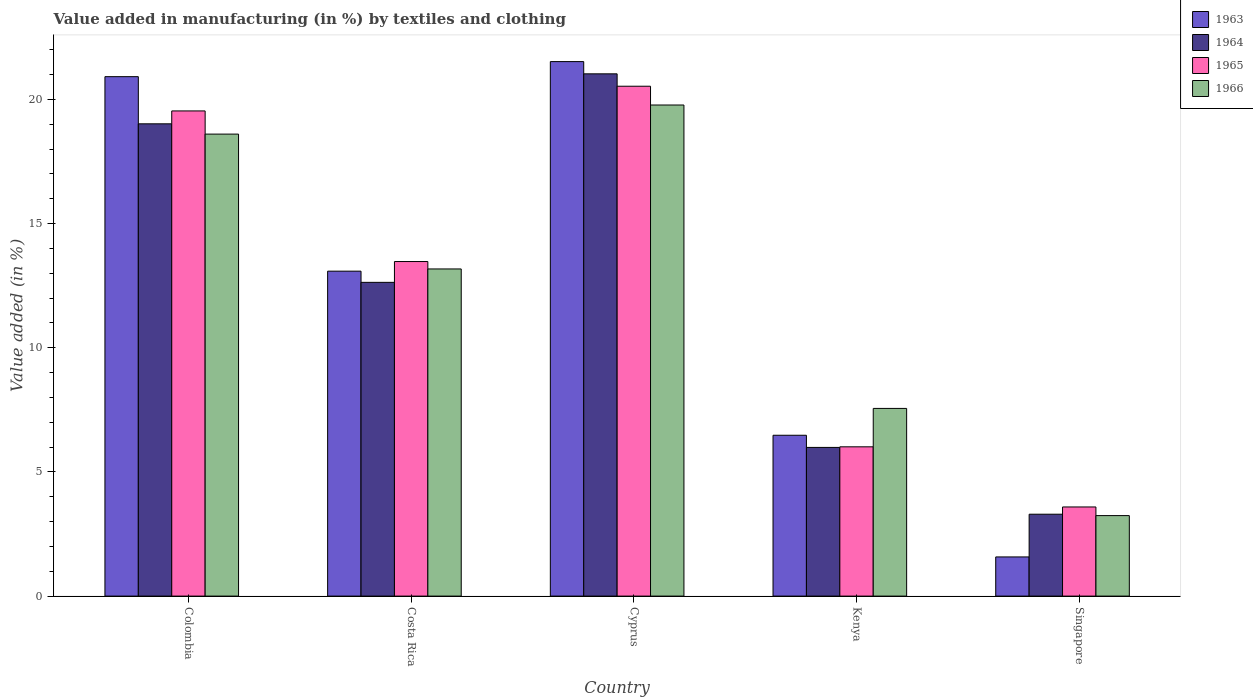How many groups of bars are there?
Keep it short and to the point. 5. Are the number of bars per tick equal to the number of legend labels?
Your answer should be compact. Yes. How many bars are there on the 3rd tick from the left?
Provide a succinct answer. 4. What is the percentage of value added in manufacturing by textiles and clothing in 1963 in Colombia?
Provide a succinct answer. 20.92. Across all countries, what is the maximum percentage of value added in manufacturing by textiles and clothing in 1964?
Provide a succinct answer. 21.03. Across all countries, what is the minimum percentage of value added in manufacturing by textiles and clothing in 1965?
Your answer should be very brief. 3.59. In which country was the percentage of value added in manufacturing by textiles and clothing in 1963 maximum?
Provide a succinct answer. Cyprus. In which country was the percentage of value added in manufacturing by textiles and clothing in 1963 minimum?
Provide a succinct answer. Singapore. What is the total percentage of value added in manufacturing by textiles and clothing in 1963 in the graph?
Make the answer very short. 63.58. What is the difference between the percentage of value added in manufacturing by textiles and clothing in 1964 in Cyprus and that in Singapore?
Keep it short and to the point. 17.73. What is the difference between the percentage of value added in manufacturing by textiles and clothing in 1965 in Costa Rica and the percentage of value added in manufacturing by textiles and clothing in 1966 in Kenya?
Offer a very short reply. 5.91. What is the average percentage of value added in manufacturing by textiles and clothing in 1963 per country?
Give a very brief answer. 12.72. What is the difference between the percentage of value added in manufacturing by textiles and clothing of/in 1966 and percentage of value added in manufacturing by textiles and clothing of/in 1963 in Costa Rica?
Your answer should be very brief. 0.09. In how many countries, is the percentage of value added in manufacturing by textiles and clothing in 1966 greater than 7 %?
Offer a very short reply. 4. What is the ratio of the percentage of value added in manufacturing by textiles and clothing in 1966 in Colombia to that in Costa Rica?
Your answer should be compact. 1.41. Is the percentage of value added in manufacturing by textiles and clothing in 1964 in Colombia less than that in Singapore?
Keep it short and to the point. No. What is the difference between the highest and the second highest percentage of value added in manufacturing by textiles and clothing in 1966?
Keep it short and to the point. -1.17. What is the difference between the highest and the lowest percentage of value added in manufacturing by textiles and clothing in 1964?
Your response must be concise. 17.73. Is the sum of the percentage of value added in manufacturing by textiles and clothing in 1966 in Cyprus and Kenya greater than the maximum percentage of value added in manufacturing by textiles and clothing in 1965 across all countries?
Provide a succinct answer. Yes. Is it the case that in every country, the sum of the percentage of value added in manufacturing by textiles and clothing in 1964 and percentage of value added in manufacturing by textiles and clothing in 1966 is greater than the sum of percentage of value added in manufacturing by textiles and clothing in 1965 and percentage of value added in manufacturing by textiles and clothing in 1963?
Offer a terse response. No. What does the 3rd bar from the left in Costa Rica represents?
Ensure brevity in your answer.  1965. What does the 2nd bar from the right in Colombia represents?
Your answer should be very brief. 1965. Is it the case that in every country, the sum of the percentage of value added in manufacturing by textiles and clothing in 1965 and percentage of value added in manufacturing by textiles and clothing in 1963 is greater than the percentage of value added in manufacturing by textiles and clothing in 1966?
Make the answer very short. Yes. Are all the bars in the graph horizontal?
Your answer should be very brief. No. What is the difference between two consecutive major ticks on the Y-axis?
Your answer should be compact. 5. How many legend labels are there?
Your answer should be compact. 4. What is the title of the graph?
Your response must be concise. Value added in manufacturing (in %) by textiles and clothing. Does "2013" appear as one of the legend labels in the graph?
Provide a short and direct response. No. What is the label or title of the Y-axis?
Provide a succinct answer. Value added (in %). What is the Value added (in %) in 1963 in Colombia?
Your response must be concise. 20.92. What is the Value added (in %) of 1964 in Colombia?
Your response must be concise. 19.02. What is the Value added (in %) in 1965 in Colombia?
Ensure brevity in your answer.  19.54. What is the Value added (in %) of 1966 in Colombia?
Provide a succinct answer. 18.6. What is the Value added (in %) of 1963 in Costa Rica?
Offer a very short reply. 13.08. What is the Value added (in %) of 1964 in Costa Rica?
Provide a short and direct response. 12.63. What is the Value added (in %) in 1965 in Costa Rica?
Keep it short and to the point. 13.47. What is the Value added (in %) in 1966 in Costa Rica?
Keep it short and to the point. 13.17. What is the Value added (in %) of 1963 in Cyprus?
Ensure brevity in your answer.  21.52. What is the Value added (in %) in 1964 in Cyprus?
Offer a very short reply. 21.03. What is the Value added (in %) of 1965 in Cyprus?
Your response must be concise. 20.53. What is the Value added (in %) in 1966 in Cyprus?
Your answer should be very brief. 19.78. What is the Value added (in %) of 1963 in Kenya?
Offer a terse response. 6.48. What is the Value added (in %) of 1964 in Kenya?
Give a very brief answer. 5.99. What is the Value added (in %) of 1965 in Kenya?
Ensure brevity in your answer.  6.01. What is the Value added (in %) in 1966 in Kenya?
Ensure brevity in your answer.  7.56. What is the Value added (in %) of 1963 in Singapore?
Your answer should be compact. 1.58. What is the Value added (in %) of 1964 in Singapore?
Your response must be concise. 3.3. What is the Value added (in %) in 1965 in Singapore?
Ensure brevity in your answer.  3.59. What is the Value added (in %) in 1966 in Singapore?
Your answer should be very brief. 3.24. Across all countries, what is the maximum Value added (in %) in 1963?
Keep it short and to the point. 21.52. Across all countries, what is the maximum Value added (in %) in 1964?
Make the answer very short. 21.03. Across all countries, what is the maximum Value added (in %) in 1965?
Your response must be concise. 20.53. Across all countries, what is the maximum Value added (in %) of 1966?
Your response must be concise. 19.78. Across all countries, what is the minimum Value added (in %) of 1963?
Your answer should be compact. 1.58. Across all countries, what is the minimum Value added (in %) in 1964?
Make the answer very short. 3.3. Across all countries, what is the minimum Value added (in %) of 1965?
Make the answer very short. 3.59. Across all countries, what is the minimum Value added (in %) of 1966?
Your answer should be very brief. 3.24. What is the total Value added (in %) in 1963 in the graph?
Provide a succinct answer. 63.58. What is the total Value added (in %) in 1964 in the graph?
Give a very brief answer. 61.97. What is the total Value added (in %) in 1965 in the graph?
Make the answer very short. 63.14. What is the total Value added (in %) in 1966 in the graph?
Keep it short and to the point. 62.35. What is the difference between the Value added (in %) in 1963 in Colombia and that in Costa Rica?
Your response must be concise. 7.83. What is the difference between the Value added (in %) of 1964 in Colombia and that in Costa Rica?
Ensure brevity in your answer.  6.38. What is the difference between the Value added (in %) of 1965 in Colombia and that in Costa Rica?
Offer a terse response. 6.06. What is the difference between the Value added (in %) in 1966 in Colombia and that in Costa Rica?
Provide a succinct answer. 5.43. What is the difference between the Value added (in %) in 1963 in Colombia and that in Cyprus?
Provide a short and direct response. -0.61. What is the difference between the Value added (in %) of 1964 in Colombia and that in Cyprus?
Your answer should be very brief. -2.01. What is the difference between the Value added (in %) of 1965 in Colombia and that in Cyprus?
Ensure brevity in your answer.  -0.99. What is the difference between the Value added (in %) of 1966 in Colombia and that in Cyprus?
Give a very brief answer. -1.17. What is the difference between the Value added (in %) in 1963 in Colombia and that in Kenya?
Offer a very short reply. 14.44. What is the difference between the Value added (in %) of 1964 in Colombia and that in Kenya?
Your answer should be compact. 13.03. What is the difference between the Value added (in %) of 1965 in Colombia and that in Kenya?
Give a very brief answer. 13.53. What is the difference between the Value added (in %) in 1966 in Colombia and that in Kenya?
Provide a succinct answer. 11.05. What is the difference between the Value added (in %) of 1963 in Colombia and that in Singapore?
Give a very brief answer. 19.34. What is the difference between the Value added (in %) in 1964 in Colombia and that in Singapore?
Offer a very short reply. 15.72. What is the difference between the Value added (in %) in 1965 in Colombia and that in Singapore?
Make the answer very short. 15.95. What is the difference between the Value added (in %) in 1966 in Colombia and that in Singapore?
Offer a terse response. 15.36. What is the difference between the Value added (in %) of 1963 in Costa Rica and that in Cyprus?
Make the answer very short. -8.44. What is the difference between the Value added (in %) in 1964 in Costa Rica and that in Cyprus?
Offer a terse response. -8.4. What is the difference between the Value added (in %) in 1965 in Costa Rica and that in Cyprus?
Your answer should be compact. -7.06. What is the difference between the Value added (in %) of 1966 in Costa Rica and that in Cyprus?
Your answer should be very brief. -6.6. What is the difference between the Value added (in %) of 1963 in Costa Rica and that in Kenya?
Your answer should be very brief. 6.61. What is the difference between the Value added (in %) in 1964 in Costa Rica and that in Kenya?
Your answer should be very brief. 6.65. What is the difference between the Value added (in %) in 1965 in Costa Rica and that in Kenya?
Your answer should be compact. 7.46. What is the difference between the Value added (in %) of 1966 in Costa Rica and that in Kenya?
Your response must be concise. 5.62. What is the difference between the Value added (in %) in 1963 in Costa Rica and that in Singapore?
Your answer should be very brief. 11.51. What is the difference between the Value added (in %) in 1964 in Costa Rica and that in Singapore?
Make the answer very short. 9.34. What is the difference between the Value added (in %) in 1965 in Costa Rica and that in Singapore?
Your answer should be very brief. 9.88. What is the difference between the Value added (in %) of 1966 in Costa Rica and that in Singapore?
Your answer should be very brief. 9.93. What is the difference between the Value added (in %) in 1963 in Cyprus and that in Kenya?
Your answer should be very brief. 15.05. What is the difference between the Value added (in %) of 1964 in Cyprus and that in Kenya?
Your response must be concise. 15.04. What is the difference between the Value added (in %) of 1965 in Cyprus and that in Kenya?
Your response must be concise. 14.52. What is the difference between the Value added (in %) in 1966 in Cyprus and that in Kenya?
Provide a short and direct response. 12.22. What is the difference between the Value added (in %) in 1963 in Cyprus and that in Singapore?
Offer a terse response. 19.95. What is the difference between the Value added (in %) of 1964 in Cyprus and that in Singapore?
Offer a very short reply. 17.73. What is the difference between the Value added (in %) of 1965 in Cyprus and that in Singapore?
Provide a succinct answer. 16.94. What is the difference between the Value added (in %) in 1966 in Cyprus and that in Singapore?
Offer a very short reply. 16.53. What is the difference between the Value added (in %) of 1963 in Kenya and that in Singapore?
Offer a very short reply. 4.9. What is the difference between the Value added (in %) in 1964 in Kenya and that in Singapore?
Offer a very short reply. 2.69. What is the difference between the Value added (in %) of 1965 in Kenya and that in Singapore?
Ensure brevity in your answer.  2.42. What is the difference between the Value added (in %) of 1966 in Kenya and that in Singapore?
Keep it short and to the point. 4.32. What is the difference between the Value added (in %) of 1963 in Colombia and the Value added (in %) of 1964 in Costa Rica?
Keep it short and to the point. 8.28. What is the difference between the Value added (in %) in 1963 in Colombia and the Value added (in %) in 1965 in Costa Rica?
Your answer should be compact. 7.44. What is the difference between the Value added (in %) in 1963 in Colombia and the Value added (in %) in 1966 in Costa Rica?
Offer a terse response. 7.74. What is the difference between the Value added (in %) in 1964 in Colombia and the Value added (in %) in 1965 in Costa Rica?
Make the answer very short. 5.55. What is the difference between the Value added (in %) of 1964 in Colombia and the Value added (in %) of 1966 in Costa Rica?
Your answer should be very brief. 5.84. What is the difference between the Value added (in %) in 1965 in Colombia and the Value added (in %) in 1966 in Costa Rica?
Offer a very short reply. 6.36. What is the difference between the Value added (in %) of 1963 in Colombia and the Value added (in %) of 1964 in Cyprus?
Offer a terse response. -0.11. What is the difference between the Value added (in %) in 1963 in Colombia and the Value added (in %) in 1965 in Cyprus?
Give a very brief answer. 0.39. What is the difference between the Value added (in %) in 1963 in Colombia and the Value added (in %) in 1966 in Cyprus?
Ensure brevity in your answer.  1.14. What is the difference between the Value added (in %) of 1964 in Colombia and the Value added (in %) of 1965 in Cyprus?
Keep it short and to the point. -1.51. What is the difference between the Value added (in %) of 1964 in Colombia and the Value added (in %) of 1966 in Cyprus?
Make the answer very short. -0.76. What is the difference between the Value added (in %) of 1965 in Colombia and the Value added (in %) of 1966 in Cyprus?
Provide a succinct answer. -0.24. What is the difference between the Value added (in %) of 1963 in Colombia and the Value added (in %) of 1964 in Kenya?
Offer a very short reply. 14.93. What is the difference between the Value added (in %) of 1963 in Colombia and the Value added (in %) of 1965 in Kenya?
Your response must be concise. 14.91. What is the difference between the Value added (in %) of 1963 in Colombia and the Value added (in %) of 1966 in Kenya?
Give a very brief answer. 13.36. What is the difference between the Value added (in %) of 1964 in Colombia and the Value added (in %) of 1965 in Kenya?
Keep it short and to the point. 13.01. What is the difference between the Value added (in %) of 1964 in Colombia and the Value added (in %) of 1966 in Kenya?
Provide a short and direct response. 11.46. What is the difference between the Value added (in %) in 1965 in Colombia and the Value added (in %) in 1966 in Kenya?
Your answer should be very brief. 11.98. What is the difference between the Value added (in %) of 1963 in Colombia and the Value added (in %) of 1964 in Singapore?
Keep it short and to the point. 17.62. What is the difference between the Value added (in %) in 1963 in Colombia and the Value added (in %) in 1965 in Singapore?
Offer a terse response. 17.33. What is the difference between the Value added (in %) of 1963 in Colombia and the Value added (in %) of 1966 in Singapore?
Offer a very short reply. 17.68. What is the difference between the Value added (in %) of 1964 in Colombia and the Value added (in %) of 1965 in Singapore?
Your answer should be compact. 15.43. What is the difference between the Value added (in %) in 1964 in Colombia and the Value added (in %) in 1966 in Singapore?
Keep it short and to the point. 15.78. What is the difference between the Value added (in %) in 1965 in Colombia and the Value added (in %) in 1966 in Singapore?
Make the answer very short. 16.3. What is the difference between the Value added (in %) of 1963 in Costa Rica and the Value added (in %) of 1964 in Cyprus?
Your answer should be very brief. -7.95. What is the difference between the Value added (in %) of 1963 in Costa Rica and the Value added (in %) of 1965 in Cyprus?
Your answer should be very brief. -7.45. What is the difference between the Value added (in %) in 1963 in Costa Rica and the Value added (in %) in 1966 in Cyprus?
Provide a short and direct response. -6.69. What is the difference between the Value added (in %) in 1964 in Costa Rica and the Value added (in %) in 1965 in Cyprus?
Ensure brevity in your answer.  -7.9. What is the difference between the Value added (in %) of 1964 in Costa Rica and the Value added (in %) of 1966 in Cyprus?
Provide a short and direct response. -7.14. What is the difference between the Value added (in %) of 1965 in Costa Rica and the Value added (in %) of 1966 in Cyprus?
Give a very brief answer. -6.3. What is the difference between the Value added (in %) in 1963 in Costa Rica and the Value added (in %) in 1964 in Kenya?
Your answer should be very brief. 7.1. What is the difference between the Value added (in %) in 1963 in Costa Rica and the Value added (in %) in 1965 in Kenya?
Keep it short and to the point. 7.07. What is the difference between the Value added (in %) in 1963 in Costa Rica and the Value added (in %) in 1966 in Kenya?
Provide a succinct answer. 5.53. What is the difference between the Value added (in %) in 1964 in Costa Rica and the Value added (in %) in 1965 in Kenya?
Ensure brevity in your answer.  6.62. What is the difference between the Value added (in %) in 1964 in Costa Rica and the Value added (in %) in 1966 in Kenya?
Ensure brevity in your answer.  5.08. What is the difference between the Value added (in %) of 1965 in Costa Rica and the Value added (in %) of 1966 in Kenya?
Your response must be concise. 5.91. What is the difference between the Value added (in %) in 1963 in Costa Rica and the Value added (in %) in 1964 in Singapore?
Your answer should be compact. 9.79. What is the difference between the Value added (in %) of 1963 in Costa Rica and the Value added (in %) of 1965 in Singapore?
Keep it short and to the point. 9.5. What is the difference between the Value added (in %) in 1963 in Costa Rica and the Value added (in %) in 1966 in Singapore?
Your answer should be very brief. 9.84. What is the difference between the Value added (in %) in 1964 in Costa Rica and the Value added (in %) in 1965 in Singapore?
Your response must be concise. 9.04. What is the difference between the Value added (in %) in 1964 in Costa Rica and the Value added (in %) in 1966 in Singapore?
Ensure brevity in your answer.  9.39. What is the difference between the Value added (in %) of 1965 in Costa Rica and the Value added (in %) of 1966 in Singapore?
Your response must be concise. 10.23. What is the difference between the Value added (in %) of 1963 in Cyprus and the Value added (in %) of 1964 in Kenya?
Ensure brevity in your answer.  15.54. What is the difference between the Value added (in %) of 1963 in Cyprus and the Value added (in %) of 1965 in Kenya?
Your answer should be very brief. 15.51. What is the difference between the Value added (in %) of 1963 in Cyprus and the Value added (in %) of 1966 in Kenya?
Provide a succinct answer. 13.97. What is the difference between the Value added (in %) in 1964 in Cyprus and the Value added (in %) in 1965 in Kenya?
Keep it short and to the point. 15.02. What is the difference between the Value added (in %) in 1964 in Cyprus and the Value added (in %) in 1966 in Kenya?
Provide a succinct answer. 13.47. What is the difference between the Value added (in %) of 1965 in Cyprus and the Value added (in %) of 1966 in Kenya?
Give a very brief answer. 12.97. What is the difference between the Value added (in %) of 1963 in Cyprus and the Value added (in %) of 1964 in Singapore?
Provide a short and direct response. 18.23. What is the difference between the Value added (in %) of 1963 in Cyprus and the Value added (in %) of 1965 in Singapore?
Give a very brief answer. 17.93. What is the difference between the Value added (in %) in 1963 in Cyprus and the Value added (in %) in 1966 in Singapore?
Give a very brief answer. 18.28. What is the difference between the Value added (in %) of 1964 in Cyprus and the Value added (in %) of 1965 in Singapore?
Ensure brevity in your answer.  17.44. What is the difference between the Value added (in %) in 1964 in Cyprus and the Value added (in %) in 1966 in Singapore?
Your answer should be very brief. 17.79. What is the difference between the Value added (in %) of 1965 in Cyprus and the Value added (in %) of 1966 in Singapore?
Your answer should be compact. 17.29. What is the difference between the Value added (in %) in 1963 in Kenya and the Value added (in %) in 1964 in Singapore?
Make the answer very short. 3.18. What is the difference between the Value added (in %) of 1963 in Kenya and the Value added (in %) of 1965 in Singapore?
Make the answer very short. 2.89. What is the difference between the Value added (in %) in 1963 in Kenya and the Value added (in %) in 1966 in Singapore?
Keep it short and to the point. 3.24. What is the difference between the Value added (in %) of 1964 in Kenya and the Value added (in %) of 1965 in Singapore?
Your response must be concise. 2.4. What is the difference between the Value added (in %) of 1964 in Kenya and the Value added (in %) of 1966 in Singapore?
Provide a succinct answer. 2.75. What is the difference between the Value added (in %) in 1965 in Kenya and the Value added (in %) in 1966 in Singapore?
Offer a terse response. 2.77. What is the average Value added (in %) of 1963 per country?
Keep it short and to the point. 12.72. What is the average Value added (in %) of 1964 per country?
Offer a terse response. 12.39. What is the average Value added (in %) in 1965 per country?
Keep it short and to the point. 12.63. What is the average Value added (in %) of 1966 per country?
Keep it short and to the point. 12.47. What is the difference between the Value added (in %) of 1963 and Value added (in %) of 1964 in Colombia?
Your answer should be compact. 1.9. What is the difference between the Value added (in %) in 1963 and Value added (in %) in 1965 in Colombia?
Your response must be concise. 1.38. What is the difference between the Value added (in %) of 1963 and Value added (in %) of 1966 in Colombia?
Provide a succinct answer. 2.31. What is the difference between the Value added (in %) in 1964 and Value added (in %) in 1965 in Colombia?
Your answer should be compact. -0.52. What is the difference between the Value added (in %) of 1964 and Value added (in %) of 1966 in Colombia?
Provide a short and direct response. 0.41. What is the difference between the Value added (in %) in 1965 and Value added (in %) in 1966 in Colombia?
Your answer should be very brief. 0.93. What is the difference between the Value added (in %) of 1963 and Value added (in %) of 1964 in Costa Rica?
Your answer should be compact. 0.45. What is the difference between the Value added (in %) of 1963 and Value added (in %) of 1965 in Costa Rica?
Keep it short and to the point. -0.39. What is the difference between the Value added (in %) in 1963 and Value added (in %) in 1966 in Costa Rica?
Offer a terse response. -0.09. What is the difference between the Value added (in %) in 1964 and Value added (in %) in 1965 in Costa Rica?
Your answer should be very brief. -0.84. What is the difference between the Value added (in %) of 1964 and Value added (in %) of 1966 in Costa Rica?
Offer a terse response. -0.54. What is the difference between the Value added (in %) in 1965 and Value added (in %) in 1966 in Costa Rica?
Your answer should be compact. 0.3. What is the difference between the Value added (in %) of 1963 and Value added (in %) of 1964 in Cyprus?
Make the answer very short. 0.49. What is the difference between the Value added (in %) in 1963 and Value added (in %) in 1965 in Cyprus?
Ensure brevity in your answer.  0.99. What is the difference between the Value added (in %) in 1963 and Value added (in %) in 1966 in Cyprus?
Offer a terse response. 1.75. What is the difference between the Value added (in %) in 1964 and Value added (in %) in 1965 in Cyprus?
Your answer should be very brief. 0.5. What is the difference between the Value added (in %) of 1964 and Value added (in %) of 1966 in Cyprus?
Your answer should be compact. 1.25. What is the difference between the Value added (in %) in 1965 and Value added (in %) in 1966 in Cyprus?
Your answer should be very brief. 0.76. What is the difference between the Value added (in %) in 1963 and Value added (in %) in 1964 in Kenya?
Provide a short and direct response. 0.49. What is the difference between the Value added (in %) of 1963 and Value added (in %) of 1965 in Kenya?
Ensure brevity in your answer.  0.47. What is the difference between the Value added (in %) of 1963 and Value added (in %) of 1966 in Kenya?
Keep it short and to the point. -1.08. What is the difference between the Value added (in %) in 1964 and Value added (in %) in 1965 in Kenya?
Your answer should be compact. -0.02. What is the difference between the Value added (in %) of 1964 and Value added (in %) of 1966 in Kenya?
Provide a short and direct response. -1.57. What is the difference between the Value added (in %) of 1965 and Value added (in %) of 1966 in Kenya?
Offer a terse response. -1.55. What is the difference between the Value added (in %) in 1963 and Value added (in %) in 1964 in Singapore?
Provide a succinct answer. -1.72. What is the difference between the Value added (in %) in 1963 and Value added (in %) in 1965 in Singapore?
Provide a short and direct response. -2.01. What is the difference between the Value added (in %) in 1963 and Value added (in %) in 1966 in Singapore?
Provide a short and direct response. -1.66. What is the difference between the Value added (in %) in 1964 and Value added (in %) in 1965 in Singapore?
Ensure brevity in your answer.  -0.29. What is the difference between the Value added (in %) of 1964 and Value added (in %) of 1966 in Singapore?
Keep it short and to the point. 0.06. What is the difference between the Value added (in %) of 1965 and Value added (in %) of 1966 in Singapore?
Make the answer very short. 0.35. What is the ratio of the Value added (in %) in 1963 in Colombia to that in Costa Rica?
Give a very brief answer. 1.6. What is the ratio of the Value added (in %) in 1964 in Colombia to that in Costa Rica?
Give a very brief answer. 1.51. What is the ratio of the Value added (in %) of 1965 in Colombia to that in Costa Rica?
Make the answer very short. 1.45. What is the ratio of the Value added (in %) in 1966 in Colombia to that in Costa Rica?
Your answer should be very brief. 1.41. What is the ratio of the Value added (in %) in 1963 in Colombia to that in Cyprus?
Provide a short and direct response. 0.97. What is the ratio of the Value added (in %) of 1964 in Colombia to that in Cyprus?
Your answer should be very brief. 0.9. What is the ratio of the Value added (in %) in 1965 in Colombia to that in Cyprus?
Give a very brief answer. 0.95. What is the ratio of the Value added (in %) of 1966 in Colombia to that in Cyprus?
Provide a short and direct response. 0.94. What is the ratio of the Value added (in %) in 1963 in Colombia to that in Kenya?
Provide a short and direct response. 3.23. What is the ratio of the Value added (in %) in 1964 in Colombia to that in Kenya?
Give a very brief answer. 3.18. What is the ratio of the Value added (in %) of 1966 in Colombia to that in Kenya?
Provide a succinct answer. 2.46. What is the ratio of the Value added (in %) in 1963 in Colombia to that in Singapore?
Provide a succinct answer. 13.26. What is the ratio of the Value added (in %) in 1964 in Colombia to that in Singapore?
Your answer should be compact. 5.77. What is the ratio of the Value added (in %) of 1965 in Colombia to that in Singapore?
Make the answer very short. 5.44. What is the ratio of the Value added (in %) in 1966 in Colombia to that in Singapore?
Your answer should be very brief. 5.74. What is the ratio of the Value added (in %) of 1963 in Costa Rica to that in Cyprus?
Provide a succinct answer. 0.61. What is the ratio of the Value added (in %) of 1964 in Costa Rica to that in Cyprus?
Your answer should be very brief. 0.6. What is the ratio of the Value added (in %) of 1965 in Costa Rica to that in Cyprus?
Your answer should be compact. 0.66. What is the ratio of the Value added (in %) of 1966 in Costa Rica to that in Cyprus?
Offer a very short reply. 0.67. What is the ratio of the Value added (in %) in 1963 in Costa Rica to that in Kenya?
Give a very brief answer. 2.02. What is the ratio of the Value added (in %) in 1964 in Costa Rica to that in Kenya?
Offer a very short reply. 2.11. What is the ratio of the Value added (in %) of 1965 in Costa Rica to that in Kenya?
Your response must be concise. 2.24. What is the ratio of the Value added (in %) in 1966 in Costa Rica to that in Kenya?
Your answer should be very brief. 1.74. What is the ratio of the Value added (in %) in 1963 in Costa Rica to that in Singapore?
Provide a succinct answer. 8.3. What is the ratio of the Value added (in %) in 1964 in Costa Rica to that in Singapore?
Give a very brief answer. 3.83. What is the ratio of the Value added (in %) in 1965 in Costa Rica to that in Singapore?
Offer a very short reply. 3.75. What is the ratio of the Value added (in %) in 1966 in Costa Rica to that in Singapore?
Give a very brief answer. 4.06. What is the ratio of the Value added (in %) in 1963 in Cyprus to that in Kenya?
Offer a very short reply. 3.32. What is the ratio of the Value added (in %) in 1964 in Cyprus to that in Kenya?
Provide a short and direct response. 3.51. What is the ratio of the Value added (in %) of 1965 in Cyprus to that in Kenya?
Provide a short and direct response. 3.42. What is the ratio of the Value added (in %) in 1966 in Cyprus to that in Kenya?
Your response must be concise. 2.62. What is the ratio of the Value added (in %) of 1963 in Cyprus to that in Singapore?
Provide a short and direct response. 13.65. What is the ratio of the Value added (in %) in 1964 in Cyprus to that in Singapore?
Provide a short and direct response. 6.38. What is the ratio of the Value added (in %) of 1965 in Cyprus to that in Singapore?
Keep it short and to the point. 5.72. What is the ratio of the Value added (in %) of 1966 in Cyprus to that in Singapore?
Provide a succinct answer. 6.1. What is the ratio of the Value added (in %) in 1963 in Kenya to that in Singapore?
Offer a terse response. 4.11. What is the ratio of the Value added (in %) of 1964 in Kenya to that in Singapore?
Keep it short and to the point. 1.82. What is the ratio of the Value added (in %) of 1965 in Kenya to that in Singapore?
Make the answer very short. 1.67. What is the ratio of the Value added (in %) of 1966 in Kenya to that in Singapore?
Make the answer very short. 2.33. What is the difference between the highest and the second highest Value added (in %) in 1963?
Offer a very short reply. 0.61. What is the difference between the highest and the second highest Value added (in %) of 1964?
Provide a succinct answer. 2.01. What is the difference between the highest and the second highest Value added (in %) in 1966?
Offer a very short reply. 1.17. What is the difference between the highest and the lowest Value added (in %) in 1963?
Give a very brief answer. 19.95. What is the difference between the highest and the lowest Value added (in %) of 1964?
Make the answer very short. 17.73. What is the difference between the highest and the lowest Value added (in %) in 1965?
Give a very brief answer. 16.94. What is the difference between the highest and the lowest Value added (in %) in 1966?
Make the answer very short. 16.53. 